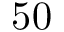Convert formula to latex. <formula><loc_0><loc_0><loc_500><loc_500>5 0</formula> 